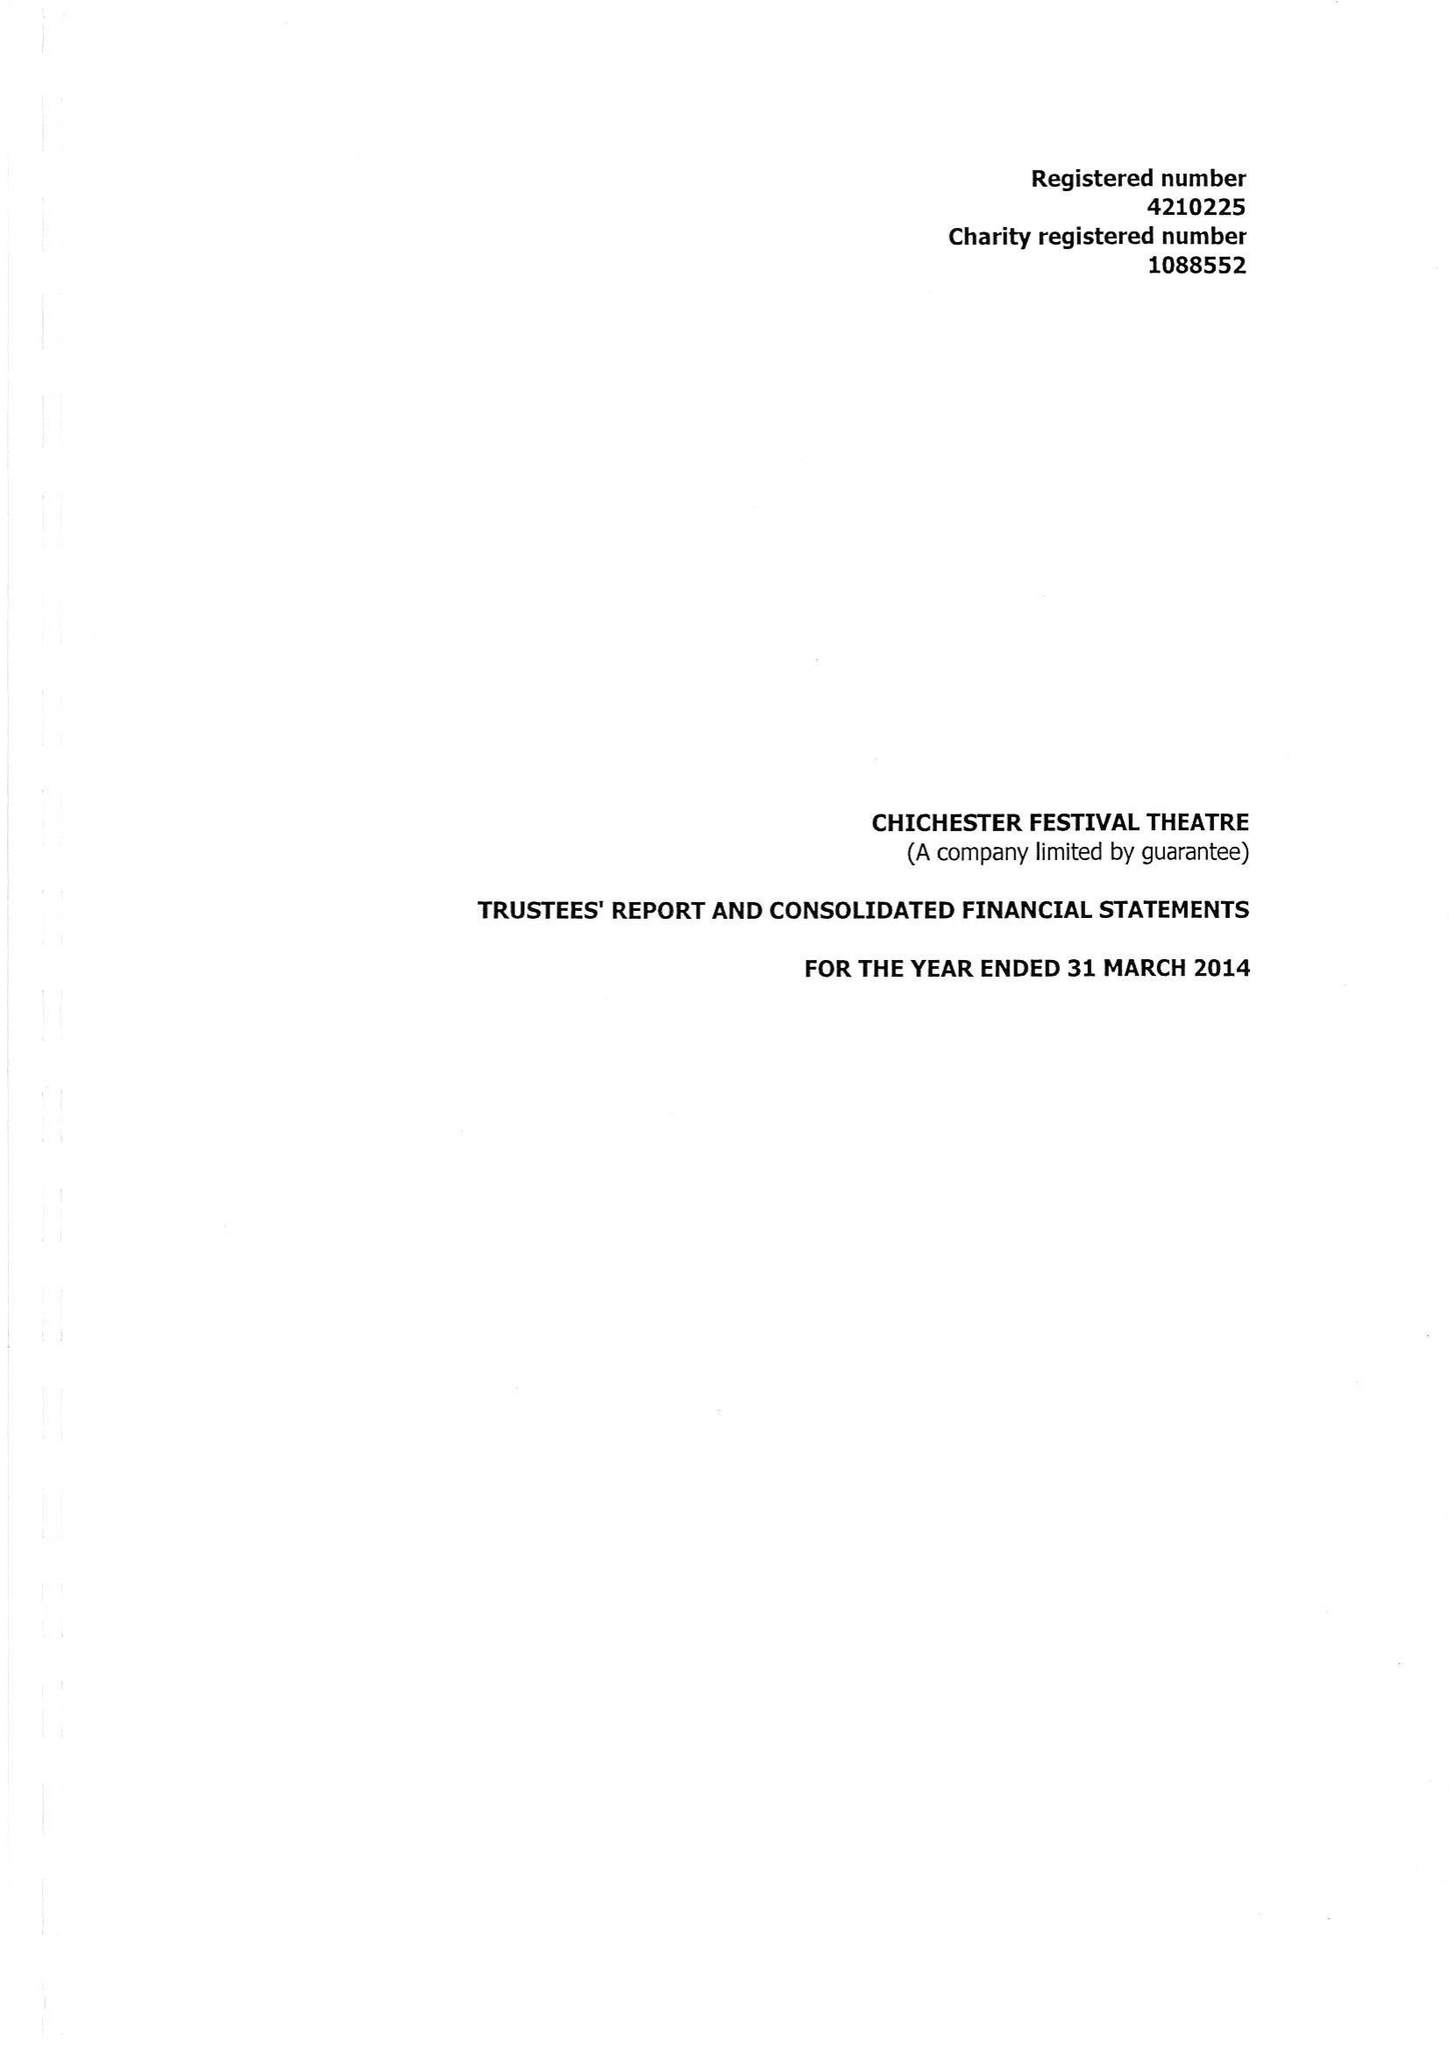What is the value for the report_date?
Answer the question using a single word or phrase. 2014-03-31 